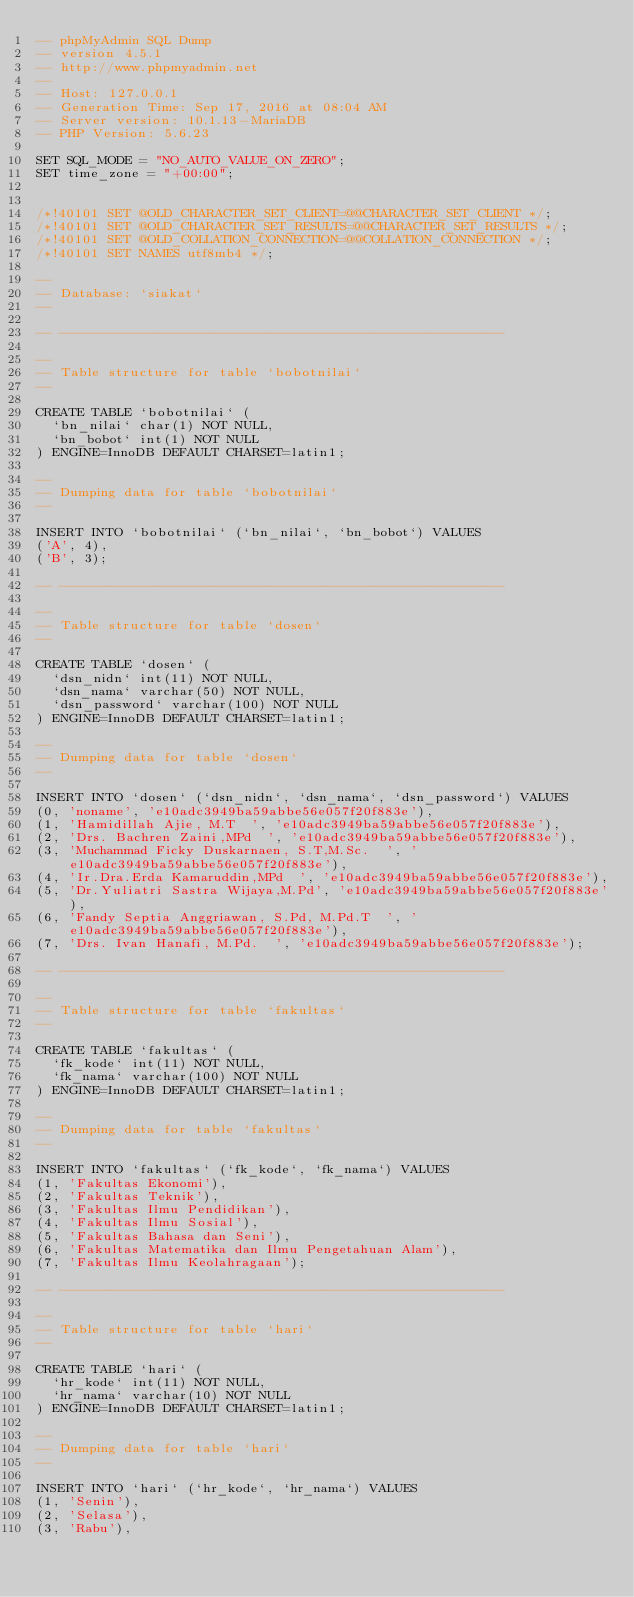<code> <loc_0><loc_0><loc_500><loc_500><_SQL_>-- phpMyAdmin SQL Dump
-- version 4.5.1
-- http://www.phpmyadmin.net
--
-- Host: 127.0.0.1
-- Generation Time: Sep 17, 2016 at 08:04 AM
-- Server version: 10.1.13-MariaDB
-- PHP Version: 5.6.23

SET SQL_MODE = "NO_AUTO_VALUE_ON_ZERO";
SET time_zone = "+00:00";


/*!40101 SET @OLD_CHARACTER_SET_CLIENT=@@CHARACTER_SET_CLIENT */;
/*!40101 SET @OLD_CHARACTER_SET_RESULTS=@@CHARACTER_SET_RESULTS */;
/*!40101 SET @OLD_COLLATION_CONNECTION=@@COLLATION_CONNECTION */;
/*!40101 SET NAMES utf8mb4 */;

--
-- Database: `siakat`
--

-- --------------------------------------------------------

--
-- Table structure for table `bobotnilai`
--

CREATE TABLE `bobotnilai` (
  `bn_nilai` char(1) NOT NULL,
  `bn_bobot` int(1) NOT NULL
) ENGINE=InnoDB DEFAULT CHARSET=latin1;

--
-- Dumping data for table `bobotnilai`
--

INSERT INTO `bobotnilai` (`bn_nilai`, `bn_bobot`) VALUES
('A', 4),
('B', 3);

-- --------------------------------------------------------

--
-- Table structure for table `dosen`
--

CREATE TABLE `dosen` (
  `dsn_nidn` int(11) NOT NULL,
  `dsn_nama` varchar(50) NOT NULL,
  `dsn_password` varchar(100) NOT NULL
) ENGINE=InnoDB DEFAULT CHARSET=latin1;

--
-- Dumping data for table `dosen`
--

INSERT INTO `dosen` (`dsn_nidn`, `dsn_nama`, `dsn_password`) VALUES
(0, 'noname', 'e10adc3949ba59abbe56e057f20f883e'),
(1, 'Hamidillah Ajie, M.T  ', 'e10adc3949ba59abbe56e057f20f883e'),
(2, 'Drs. Bachren Zaini,MPd  ', 'e10adc3949ba59abbe56e057f20f883e'),
(3, 'Muchammad Ficky Duskarnaen, S.T,M.Sc.  ', 'e10adc3949ba59abbe56e057f20f883e'),
(4, 'Ir.Dra.Erda Kamaruddin,MPd  ', 'e10adc3949ba59abbe56e057f20f883e'),
(5, 'Dr.Yuliatri Sastra Wijaya,M.Pd', 'e10adc3949ba59abbe56e057f20f883e'),
(6, 'Fandy Septia Anggriawan, S.Pd, M.Pd.T  ', 'e10adc3949ba59abbe56e057f20f883e'),
(7, 'Drs. Ivan Hanafi, M.Pd.  ', 'e10adc3949ba59abbe56e057f20f883e');

-- --------------------------------------------------------

--
-- Table structure for table `fakultas`
--

CREATE TABLE `fakultas` (
  `fk_kode` int(11) NOT NULL,
  `fk_nama` varchar(100) NOT NULL
) ENGINE=InnoDB DEFAULT CHARSET=latin1;

--
-- Dumping data for table `fakultas`
--

INSERT INTO `fakultas` (`fk_kode`, `fk_nama`) VALUES
(1, 'Fakultas Ekonomi'),
(2, 'Fakultas Teknik'),
(3, 'Fakultas Ilmu Pendidikan'),
(4, 'Fakultas Ilmu Sosial'),
(5, 'Fakultas Bahasa dan Seni'),
(6, 'Fakultas Matematika dan Ilmu Pengetahuan Alam'),
(7, 'Fakultas Ilmu Keolahragaan');

-- --------------------------------------------------------

--
-- Table structure for table `hari`
--

CREATE TABLE `hari` (
  `hr_kode` int(11) NOT NULL,
  `hr_nama` varchar(10) NOT NULL
) ENGINE=InnoDB DEFAULT CHARSET=latin1;

--
-- Dumping data for table `hari`
--

INSERT INTO `hari` (`hr_kode`, `hr_nama`) VALUES
(1, 'Senin'),
(2, 'Selasa'),
(3, 'Rabu'),</code> 